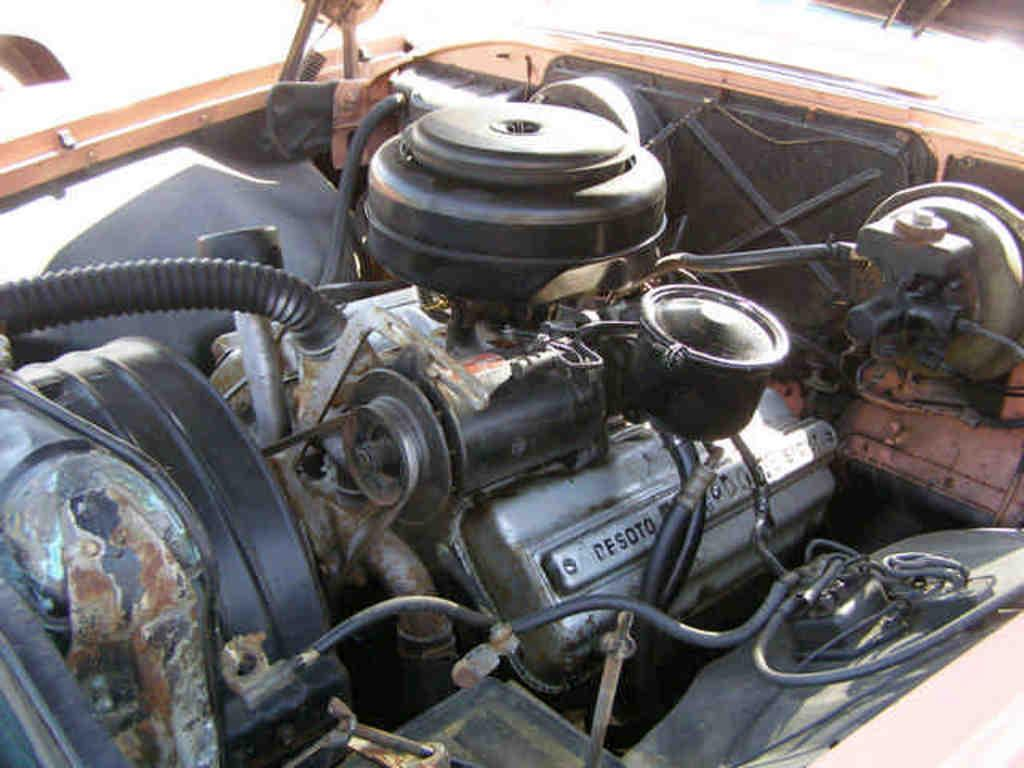What is the main subject of the image? The main subject of the image is the engine of a car. What can be seen inside the engine? The image shows some inner parts of the car. What is the color of the background in the image? The background of the image is white in color. Can you describe the weather or lighting conditions in the image? It is likely a sunny day in the image, as the white background suggests bright lighting. Where is the nest located in the image? There is no nest present in the image; it features an engine of a car with some inner parts visible. What type of steel is used to construct the engine in the image? The image does not provide information about the type of steel used in the engine's construction. 